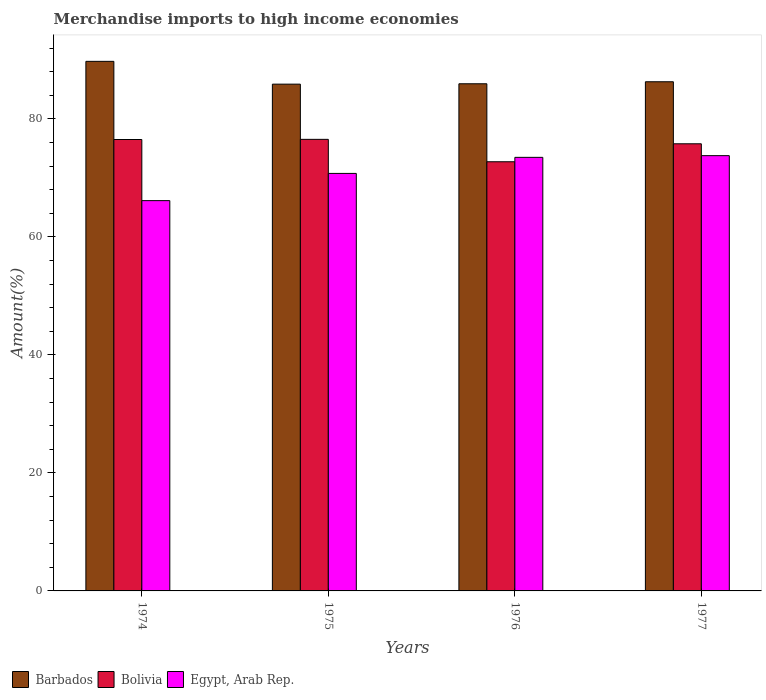How many groups of bars are there?
Your response must be concise. 4. How many bars are there on the 4th tick from the right?
Your answer should be very brief. 3. What is the label of the 1st group of bars from the left?
Your answer should be compact. 1974. In how many cases, is the number of bars for a given year not equal to the number of legend labels?
Make the answer very short. 0. What is the percentage of amount earned from merchandise imports in Barbados in 1977?
Give a very brief answer. 86.3. Across all years, what is the maximum percentage of amount earned from merchandise imports in Egypt, Arab Rep.?
Your answer should be compact. 73.77. Across all years, what is the minimum percentage of amount earned from merchandise imports in Egypt, Arab Rep.?
Your answer should be compact. 66.15. In which year was the percentage of amount earned from merchandise imports in Bolivia maximum?
Ensure brevity in your answer.  1975. In which year was the percentage of amount earned from merchandise imports in Bolivia minimum?
Keep it short and to the point. 1976. What is the total percentage of amount earned from merchandise imports in Bolivia in the graph?
Your response must be concise. 301.57. What is the difference between the percentage of amount earned from merchandise imports in Egypt, Arab Rep. in 1974 and that in 1976?
Your response must be concise. -7.34. What is the difference between the percentage of amount earned from merchandise imports in Barbados in 1976 and the percentage of amount earned from merchandise imports in Egypt, Arab Rep. in 1974?
Offer a very short reply. 19.81. What is the average percentage of amount earned from merchandise imports in Egypt, Arab Rep. per year?
Your response must be concise. 71.04. In the year 1974, what is the difference between the percentage of amount earned from merchandise imports in Egypt, Arab Rep. and percentage of amount earned from merchandise imports in Barbados?
Make the answer very short. -23.61. What is the ratio of the percentage of amount earned from merchandise imports in Bolivia in 1976 to that in 1977?
Give a very brief answer. 0.96. Is the percentage of amount earned from merchandise imports in Egypt, Arab Rep. in 1975 less than that in 1977?
Your answer should be compact. Yes. What is the difference between the highest and the second highest percentage of amount earned from merchandise imports in Egypt, Arab Rep.?
Provide a short and direct response. 0.29. What is the difference between the highest and the lowest percentage of amount earned from merchandise imports in Bolivia?
Your response must be concise. 3.8. Is the sum of the percentage of amount earned from merchandise imports in Bolivia in 1974 and 1976 greater than the maximum percentage of amount earned from merchandise imports in Barbados across all years?
Your answer should be compact. Yes. Is it the case that in every year, the sum of the percentage of amount earned from merchandise imports in Bolivia and percentage of amount earned from merchandise imports in Egypt, Arab Rep. is greater than the percentage of amount earned from merchandise imports in Barbados?
Offer a terse response. Yes. Are all the bars in the graph horizontal?
Your answer should be compact. No. Are the values on the major ticks of Y-axis written in scientific E-notation?
Keep it short and to the point. No. Does the graph contain any zero values?
Offer a terse response. No. Does the graph contain grids?
Ensure brevity in your answer.  No. How many legend labels are there?
Offer a very short reply. 3. How are the legend labels stacked?
Your answer should be very brief. Horizontal. What is the title of the graph?
Keep it short and to the point. Merchandise imports to high income economies. What is the label or title of the Y-axis?
Offer a very short reply. Amount(%). What is the Amount(%) in Barbados in 1974?
Provide a short and direct response. 89.76. What is the Amount(%) of Bolivia in 1974?
Provide a succinct answer. 76.51. What is the Amount(%) in Egypt, Arab Rep. in 1974?
Ensure brevity in your answer.  66.15. What is the Amount(%) in Barbados in 1975?
Give a very brief answer. 85.89. What is the Amount(%) in Bolivia in 1975?
Offer a very short reply. 76.54. What is the Amount(%) of Egypt, Arab Rep. in 1975?
Provide a short and direct response. 70.76. What is the Amount(%) of Barbados in 1976?
Provide a succinct answer. 85.96. What is the Amount(%) in Bolivia in 1976?
Make the answer very short. 72.74. What is the Amount(%) in Egypt, Arab Rep. in 1976?
Give a very brief answer. 73.49. What is the Amount(%) of Barbados in 1977?
Your response must be concise. 86.3. What is the Amount(%) in Bolivia in 1977?
Make the answer very short. 75.78. What is the Amount(%) in Egypt, Arab Rep. in 1977?
Offer a very short reply. 73.77. Across all years, what is the maximum Amount(%) of Barbados?
Ensure brevity in your answer.  89.76. Across all years, what is the maximum Amount(%) of Bolivia?
Your response must be concise. 76.54. Across all years, what is the maximum Amount(%) of Egypt, Arab Rep.?
Keep it short and to the point. 73.77. Across all years, what is the minimum Amount(%) in Barbados?
Provide a short and direct response. 85.89. Across all years, what is the minimum Amount(%) in Bolivia?
Offer a very short reply. 72.74. Across all years, what is the minimum Amount(%) in Egypt, Arab Rep.?
Your answer should be compact. 66.15. What is the total Amount(%) in Barbados in the graph?
Offer a terse response. 347.91. What is the total Amount(%) in Bolivia in the graph?
Keep it short and to the point. 301.57. What is the total Amount(%) of Egypt, Arab Rep. in the graph?
Give a very brief answer. 284.17. What is the difference between the Amount(%) of Barbados in 1974 and that in 1975?
Keep it short and to the point. 3.86. What is the difference between the Amount(%) in Bolivia in 1974 and that in 1975?
Your answer should be compact. -0.03. What is the difference between the Amount(%) of Egypt, Arab Rep. in 1974 and that in 1975?
Give a very brief answer. -4.61. What is the difference between the Amount(%) in Barbados in 1974 and that in 1976?
Keep it short and to the point. 3.8. What is the difference between the Amount(%) of Bolivia in 1974 and that in 1976?
Provide a short and direct response. 3.77. What is the difference between the Amount(%) of Egypt, Arab Rep. in 1974 and that in 1976?
Provide a short and direct response. -7.34. What is the difference between the Amount(%) of Barbados in 1974 and that in 1977?
Provide a succinct answer. 3.46. What is the difference between the Amount(%) in Bolivia in 1974 and that in 1977?
Make the answer very short. 0.73. What is the difference between the Amount(%) of Egypt, Arab Rep. in 1974 and that in 1977?
Your answer should be very brief. -7.62. What is the difference between the Amount(%) in Barbados in 1975 and that in 1976?
Provide a short and direct response. -0.07. What is the difference between the Amount(%) of Bolivia in 1975 and that in 1976?
Ensure brevity in your answer.  3.8. What is the difference between the Amount(%) in Egypt, Arab Rep. in 1975 and that in 1976?
Ensure brevity in your answer.  -2.72. What is the difference between the Amount(%) in Barbados in 1975 and that in 1977?
Offer a very short reply. -0.41. What is the difference between the Amount(%) of Bolivia in 1975 and that in 1977?
Your answer should be compact. 0.75. What is the difference between the Amount(%) in Egypt, Arab Rep. in 1975 and that in 1977?
Your response must be concise. -3.01. What is the difference between the Amount(%) in Barbados in 1976 and that in 1977?
Your answer should be very brief. -0.34. What is the difference between the Amount(%) of Bolivia in 1976 and that in 1977?
Give a very brief answer. -3.04. What is the difference between the Amount(%) of Egypt, Arab Rep. in 1976 and that in 1977?
Make the answer very short. -0.29. What is the difference between the Amount(%) of Barbados in 1974 and the Amount(%) of Bolivia in 1975?
Keep it short and to the point. 13.22. What is the difference between the Amount(%) in Barbados in 1974 and the Amount(%) in Egypt, Arab Rep. in 1975?
Offer a very short reply. 18.99. What is the difference between the Amount(%) in Bolivia in 1974 and the Amount(%) in Egypt, Arab Rep. in 1975?
Offer a very short reply. 5.75. What is the difference between the Amount(%) in Barbados in 1974 and the Amount(%) in Bolivia in 1976?
Ensure brevity in your answer.  17.02. What is the difference between the Amount(%) of Barbados in 1974 and the Amount(%) of Egypt, Arab Rep. in 1976?
Provide a short and direct response. 16.27. What is the difference between the Amount(%) in Bolivia in 1974 and the Amount(%) in Egypt, Arab Rep. in 1976?
Your answer should be compact. 3.02. What is the difference between the Amount(%) of Barbados in 1974 and the Amount(%) of Bolivia in 1977?
Give a very brief answer. 13.97. What is the difference between the Amount(%) of Barbados in 1974 and the Amount(%) of Egypt, Arab Rep. in 1977?
Your response must be concise. 15.98. What is the difference between the Amount(%) of Bolivia in 1974 and the Amount(%) of Egypt, Arab Rep. in 1977?
Offer a terse response. 2.74. What is the difference between the Amount(%) of Barbados in 1975 and the Amount(%) of Bolivia in 1976?
Give a very brief answer. 13.15. What is the difference between the Amount(%) in Barbados in 1975 and the Amount(%) in Egypt, Arab Rep. in 1976?
Make the answer very short. 12.41. What is the difference between the Amount(%) of Bolivia in 1975 and the Amount(%) of Egypt, Arab Rep. in 1976?
Keep it short and to the point. 3.05. What is the difference between the Amount(%) in Barbados in 1975 and the Amount(%) in Bolivia in 1977?
Offer a terse response. 10.11. What is the difference between the Amount(%) of Barbados in 1975 and the Amount(%) of Egypt, Arab Rep. in 1977?
Your response must be concise. 12.12. What is the difference between the Amount(%) in Bolivia in 1975 and the Amount(%) in Egypt, Arab Rep. in 1977?
Offer a terse response. 2.76. What is the difference between the Amount(%) in Barbados in 1976 and the Amount(%) in Bolivia in 1977?
Provide a short and direct response. 10.17. What is the difference between the Amount(%) in Barbados in 1976 and the Amount(%) in Egypt, Arab Rep. in 1977?
Give a very brief answer. 12.18. What is the difference between the Amount(%) of Bolivia in 1976 and the Amount(%) of Egypt, Arab Rep. in 1977?
Give a very brief answer. -1.03. What is the average Amount(%) of Barbados per year?
Your answer should be very brief. 86.98. What is the average Amount(%) in Bolivia per year?
Offer a terse response. 75.39. What is the average Amount(%) in Egypt, Arab Rep. per year?
Make the answer very short. 71.04. In the year 1974, what is the difference between the Amount(%) of Barbados and Amount(%) of Bolivia?
Your response must be concise. 13.25. In the year 1974, what is the difference between the Amount(%) of Barbados and Amount(%) of Egypt, Arab Rep.?
Your answer should be very brief. 23.61. In the year 1974, what is the difference between the Amount(%) in Bolivia and Amount(%) in Egypt, Arab Rep.?
Your answer should be compact. 10.36. In the year 1975, what is the difference between the Amount(%) of Barbados and Amount(%) of Bolivia?
Give a very brief answer. 9.36. In the year 1975, what is the difference between the Amount(%) in Barbados and Amount(%) in Egypt, Arab Rep.?
Give a very brief answer. 15.13. In the year 1975, what is the difference between the Amount(%) of Bolivia and Amount(%) of Egypt, Arab Rep.?
Provide a short and direct response. 5.77. In the year 1976, what is the difference between the Amount(%) of Barbados and Amount(%) of Bolivia?
Give a very brief answer. 13.22. In the year 1976, what is the difference between the Amount(%) in Barbados and Amount(%) in Egypt, Arab Rep.?
Offer a very short reply. 12.47. In the year 1976, what is the difference between the Amount(%) in Bolivia and Amount(%) in Egypt, Arab Rep.?
Give a very brief answer. -0.75. In the year 1977, what is the difference between the Amount(%) of Barbados and Amount(%) of Bolivia?
Offer a terse response. 10.52. In the year 1977, what is the difference between the Amount(%) of Barbados and Amount(%) of Egypt, Arab Rep.?
Give a very brief answer. 12.52. In the year 1977, what is the difference between the Amount(%) in Bolivia and Amount(%) in Egypt, Arab Rep.?
Give a very brief answer. 2.01. What is the ratio of the Amount(%) of Barbados in 1974 to that in 1975?
Your answer should be very brief. 1.04. What is the ratio of the Amount(%) in Bolivia in 1974 to that in 1975?
Make the answer very short. 1. What is the ratio of the Amount(%) in Egypt, Arab Rep. in 1974 to that in 1975?
Offer a very short reply. 0.93. What is the ratio of the Amount(%) in Barbados in 1974 to that in 1976?
Give a very brief answer. 1.04. What is the ratio of the Amount(%) in Bolivia in 1974 to that in 1976?
Provide a short and direct response. 1.05. What is the ratio of the Amount(%) of Egypt, Arab Rep. in 1974 to that in 1976?
Give a very brief answer. 0.9. What is the ratio of the Amount(%) in Barbados in 1974 to that in 1977?
Provide a succinct answer. 1.04. What is the ratio of the Amount(%) in Bolivia in 1974 to that in 1977?
Your response must be concise. 1.01. What is the ratio of the Amount(%) in Egypt, Arab Rep. in 1974 to that in 1977?
Give a very brief answer. 0.9. What is the ratio of the Amount(%) of Bolivia in 1975 to that in 1976?
Your response must be concise. 1.05. What is the ratio of the Amount(%) of Egypt, Arab Rep. in 1975 to that in 1976?
Provide a succinct answer. 0.96. What is the ratio of the Amount(%) of Barbados in 1975 to that in 1977?
Ensure brevity in your answer.  1. What is the ratio of the Amount(%) of Bolivia in 1975 to that in 1977?
Make the answer very short. 1.01. What is the ratio of the Amount(%) in Egypt, Arab Rep. in 1975 to that in 1977?
Your answer should be very brief. 0.96. What is the ratio of the Amount(%) in Barbados in 1976 to that in 1977?
Ensure brevity in your answer.  1. What is the ratio of the Amount(%) of Bolivia in 1976 to that in 1977?
Offer a very short reply. 0.96. What is the ratio of the Amount(%) of Egypt, Arab Rep. in 1976 to that in 1977?
Make the answer very short. 1. What is the difference between the highest and the second highest Amount(%) of Barbados?
Your answer should be very brief. 3.46. What is the difference between the highest and the second highest Amount(%) in Bolivia?
Provide a short and direct response. 0.03. What is the difference between the highest and the second highest Amount(%) in Egypt, Arab Rep.?
Ensure brevity in your answer.  0.29. What is the difference between the highest and the lowest Amount(%) in Barbados?
Make the answer very short. 3.86. What is the difference between the highest and the lowest Amount(%) in Bolivia?
Ensure brevity in your answer.  3.8. What is the difference between the highest and the lowest Amount(%) of Egypt, Arab Rep.?
Keep it short and to the point. 7.62. 